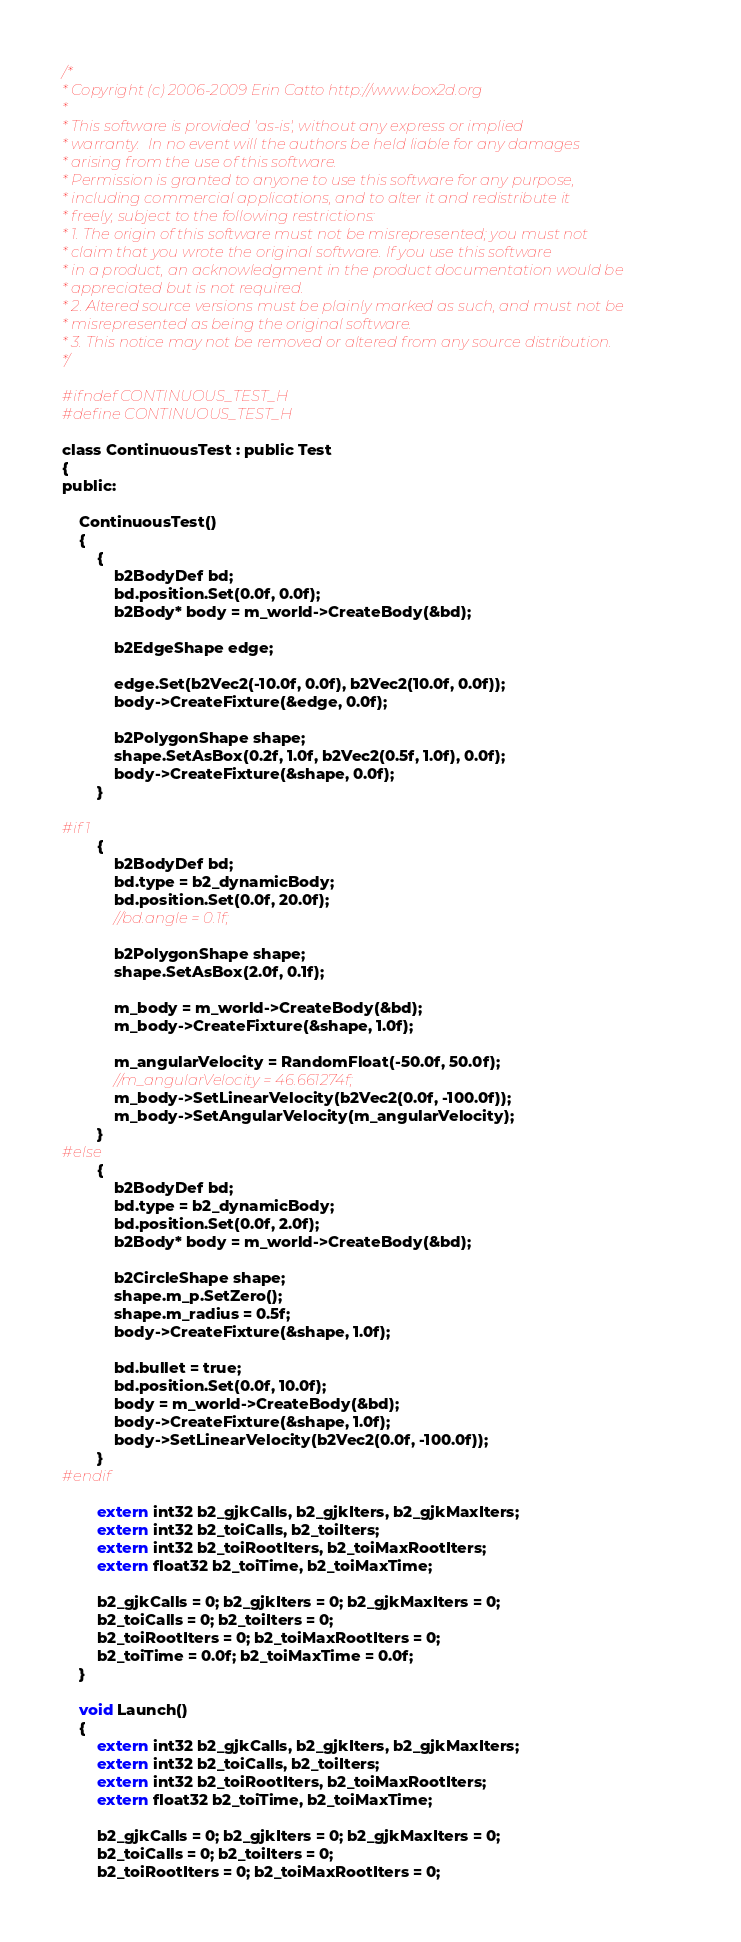<code> <loc_0><loc_0><loc_500><loc_500><_C_>/*
* Copyright (c) 2006-2009 Erin Catto http://www.box2d.org
*
* This software is provided 'as-is', without any express or implied
* warranty.  In no event will the authors be held liable for any damages
* arising from the use of this software.
* Permission is granted to anyone to use this software for any purpose,
* including commercial applications, and to alter it and redistribute it
* freely, subject to the following restrictions:
* 1. The origin of this software must not be misrepresented; you must not
* claim that you wrote the original software. If you use this software
* in a product, an acknowledgment in the product documentation would be
* appreciated but is not required.
* 2. Altered source versions must be plainly marked as such, and must not be
* misrepresented as being the original software.
* 3. This notice may not be removed or altered from any source distribution.
*/

#ifndef CONTINUOUS_TEST_H
#define CONTINUOUS_TEST_H

class ContinuousTest : public Test
{
public:

	ContinuousTest()
	{
		{
			b2BodyDef bd;
			bd.position.Set(0.0f, 0.0f);
			b2Body* body = m_world->CreateBody(&bd);

			b2EdgeShape edge;

			edge.Set(b2Vec2(-10.0f, 0.0f), b2Vec2(10.0f, 0.0f));
			body->CreateFixture(&edge, 0.0f);

			b2PolygonShape shape;
			shape.SetAsBox(0.2f, 1.0f, b2Vec2(0.5f, 1.0f), 0.0f);
			body->CreateFixture(&shape, 0.0f);
		}

#if 1
		{
			b2BodyDef bd;
			bd.type = b2_dynamicBody;
			bd.position.Set(0.0f, 20.0f);
			//bd.angle = 0.1f;

			b2PolygonShape shape;
			shape.SetAsBox(2.0f, 0.1f);

			m_body = m_world->CreateBody(&bd);
			m_body->CreateFixture(&shape, 1.0f);

			m_angularVelocity = RandomFloat(-50.0f, 50.0f);
			//m_angularVelocity = 46.661274f;
			m_body->SetLinearVelocity(b2Vec2(0.0f, -100.0f));
			m_body->SetAngularVelocity(m_angularVelocity);
		}
#else
		{
			b2BodyDef bd;
			bd.type = b2_dynamicBody;
			bd.position.Set(0.0f, 2.0f);
			b2Body* body = m_world->CreateBody(&bd);

			b2CircleShape shape;
			shape.m_p.SetZero();
			shape.m_radius = 0.5f;
			body->CreateFixture(&shape, 1.0f);

			bd.bullet = true;
			bd.position.Set(0.0f, 10.0f);
			body = m_world->CreateBody(&bd);
			body->CreateFixture(&shape, 1.0f);
			body->SetLinearVelocity(b2Vec2(0.0f, -100.0f));
		}
#endif

		extern int32 b2_gjkCalls, b2_gjkIters, b2_gjkMaxIters;
		extern int32 b2_toiCalls, b2_toiIters;
		extern int32 b2_toiRootIters, b2_toiMaxRootIters;
		extern float32 b2_toiTime, b2_toiMaxTime;

		b2_gjkCalls = 0; b2_gjkIters = 0; b2_gjkMaxIters = 0;
		b2_toiCalls = 0; b2_toiIters = 0;
		b2_toiRootIters = 0; b2_toiMaxRootIters = 0;
		b2_toiTime = 0.0f; b2_toiMaxTime = 0.0f;
	}

	void Launch()
	{
		extern int32 b2_gjkCalls, b2_gjkIters, b2_gjkMaxIters;
		extern int32 b2_toiCalls, b2_toiIters;
		extern int32 b2_toiRootIters, b2_toiMaxRootIters;
		extern float32 b2_toiTime, b2_toiMaxTime;

		b2_gjkCalls = 0; b2_gjkIters = 0; b2_gjkMaxIters = 0;
		b2_toiCalls = 0; b2_toiIters = 0;
		b2_toiRootIters = 0; b2_toiMaxRootIters = 0;</code> 